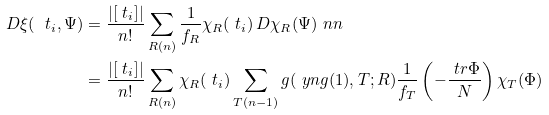Convert formula to latex. <formula><loc_0><loc_0><loc_500><loc_500>D \xi ( \ t _ { i } , \Psi ) & = \frac { | [ \ t _ { i } ] | } { n ! } \sum _ { R ( n ) } \frac { 1 } { f _ { R } } \chi _ { R } ( \ t _ { i } ) \, D \chi _ { R } ( \Psi ) \ n n \\ & = \frac { | [ \ t _ { i } ] | } { n ! } \sum _ { R ( n ) } \chi _ { R } ( \ t _ { i } ) \sum _ { T ( n - 1 ) } g ( \ y n g ( 1 ) , T ; R ) \frac { 1 } { f _ { T } } \left ( - \frac { \ t r \Phi } { N } \right ) \chi _ { T } ( \Phi )</formula> 